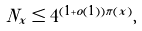<formula> <loc_0><loc_0><loc_500><loc_500>N _ { x } \leq 4 ^ { ( 1 + o ( 1 ) ) \pi ( x ) } ,</formula> 